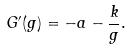Convert formula to latex. <formula><loc_0><loc_0><loc_500><loc_500>G ^ { \prime } ( g ) = - a - \frac { k } { g } .</formula> 